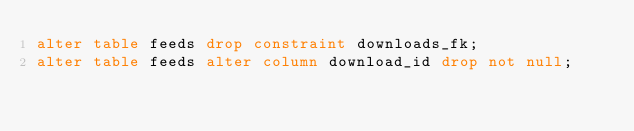Convert code to text. <code><loc_0><loc_0><loc_500><loc_500><_SQL_>alter table feeds drop constraint downloads_fk;
alter table feeds alter column download_id drop not null;
</code> 